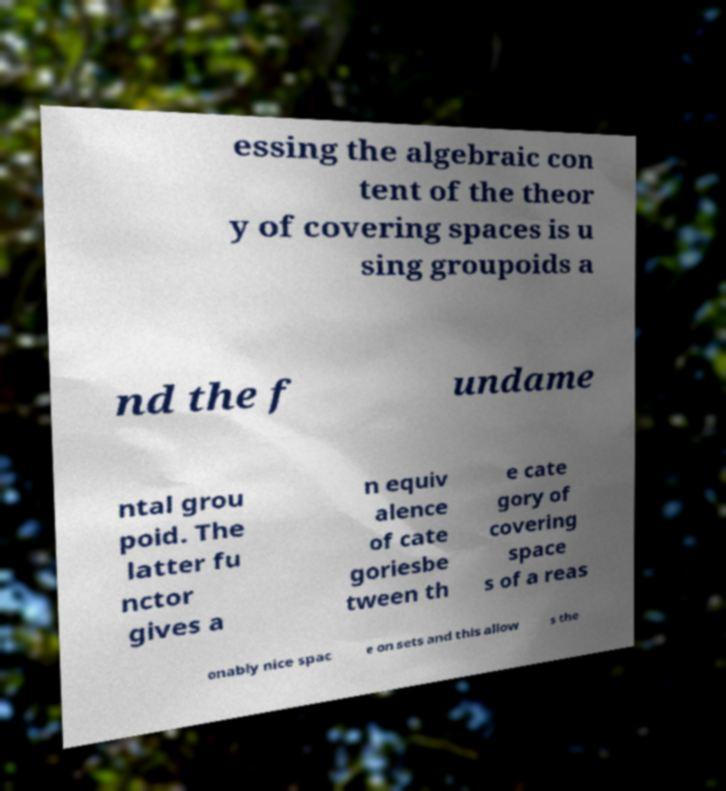Please read and relay the text visible in this image. What does it say? essing the algebraic con tent of the theor y of covering spaces is u sing groupoids a nd the f undame ntal grou poid. The latter fu nctor gives a n equiv alence of cate goriesbe tween th e cate gory of covering space s of a reas onably nice spac e on sets and this allow s the 